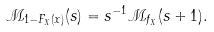<formula> <loc_0><loc_0><loc_500><loc_500>\mathcal { M } _ { 1 - F _ { X } ( x ) } ( s ) = s ^ { - 1 } \mathcal { M } _ { f _ { X } } ( s + 1 ) .</formula> 